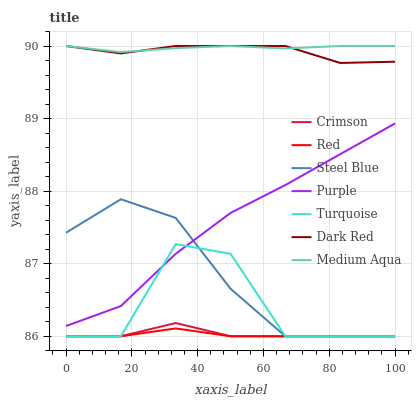Does Red have the minimum area under the curve?
Answer yes or no. Yes. Does Medium Aqua have the maximum area under the curve?
Answer yes or no. Yes. Does Purple have the minimum area under the curve?
Answer yes or no. No. Does Purple have the maximum area under the curve?
Answer yes or no. No. Is Medium Aqua the smoothest?
Answer yes or no. Yes. Is Turquoise the roughest?
Answer yes or no. Yes. Is Purple the smoothest?
Answer yes or no. No. Is Purple the roughest?
Answer yes or no. No. Does Turquoise have the lowest value?
Answer yes or no. Yes. Does Purple have the lowest value?
Answer yes or no. No. Does Medium Aqua have the highest value?
Answer yes or no. Yes. Does Purple have the highest value?
Answer yes or no. No. Is Red less than Purple?
Answer yes or no. Yes. Is Medium Aqua greater than Red?
Answer yes or no. Yes. Does Steel Blue intersect Crimson?
Answer yes or no. Yes. Is Steel Blue less than Crimson?
Answer yes or no. No. Is Steel Blue greater than Crimson?
Answer yes or no. No. Does Red intersect Purple?
Answer yes or no. No. 